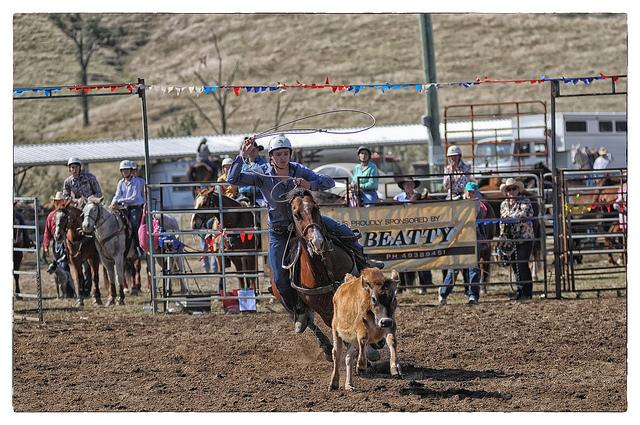What event is taking place here?
Short answer required. Rodeo. How many different types of head coverings are people wearing?
Be succinct. 2. What colors are the banners in the background?
Keep it brief. Yellow. 